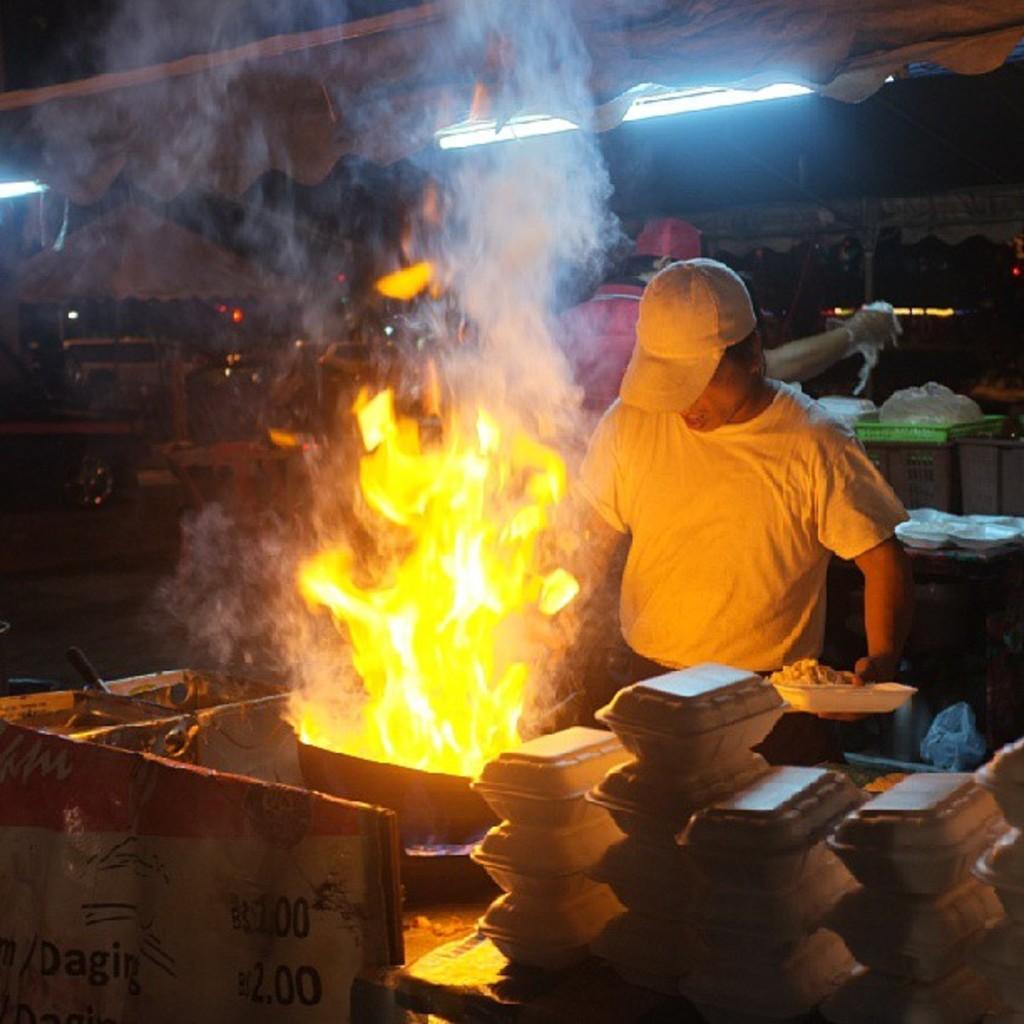In one or two sentences, can you explain what this image depicts? In this image we can see a person wearing cap. He is holding a box with some item. In front of him there is a pan with fire. And there are many boxes. In the back there are lights. Also there is smoke. And we can see a person. And there are some other items in the background. 